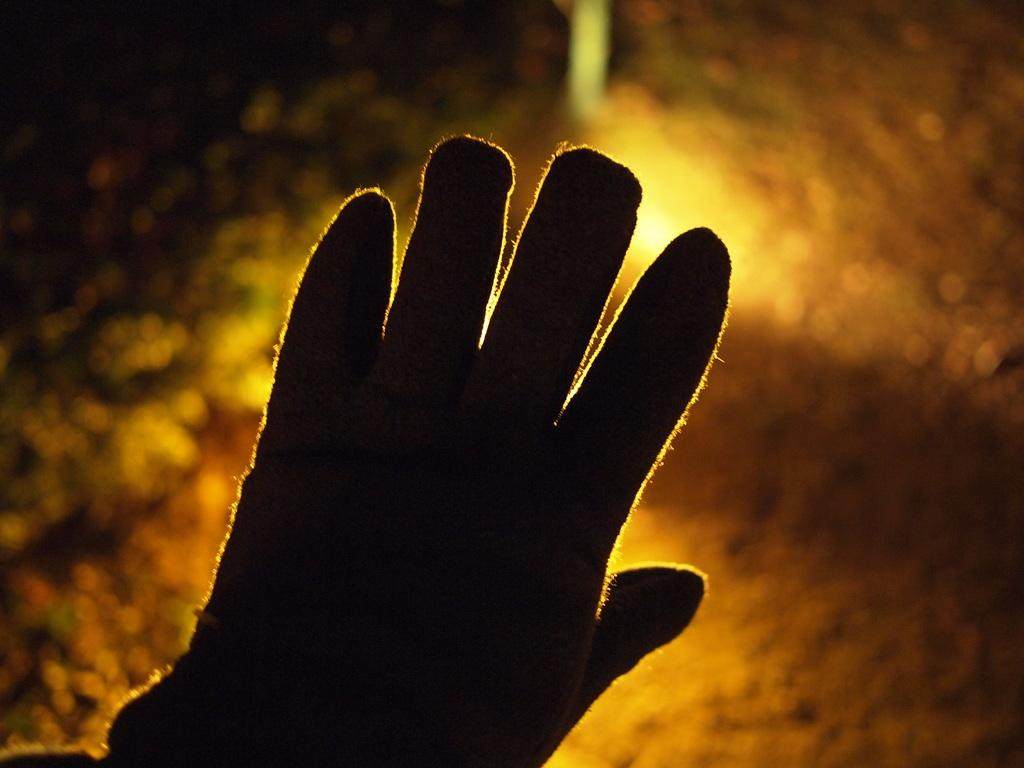What part of the person is visible in the image? There is a person's hand in the image. What is the person wearing on their hand? The person is wearing hand gloves. Can you describe the background of the image? The background of the image is unclear. How many babies are visible in the image? There are no babies present in the image; it only shows a person's hand wearing hand gloves. 